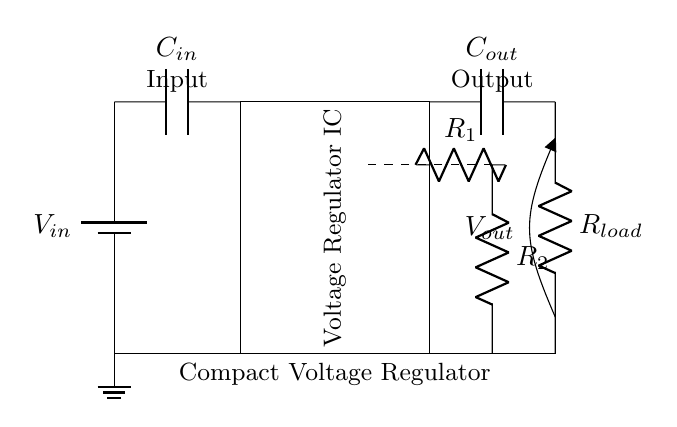What is the input voltage source labeled as? The input voltage source is labeled as V in, which indicates the voltage entering the circuit from an external battery.
Answer: V in What type of component is used to filter the input voltage? The component used to filter the input voltage is a capacitor, labeled C in, positioned immediately after the input voltage source.
Answer: C in How many resistors are present in the feedback section? There are two resistors present in the feedback section, labeled R 1 and R 2, which are critical for setting the output voltage of the regulator.
Answer: 2 What component provides the output voltage? The output voltage is provided by the load resistor, labeled R load, which connects the output capacitor to ground, allowing the load to draw current.
Answer: R load What is the label of the main voltage regulator component? The main voltage regulator component is labeled as Voltage Regulator IC, indicating it is an integrated circuit that regulates the output voltage.
Answer: Voltage Regulator IC Which capacitors are used in the circuit? The circuit uses two capacitors: one labeled C in for input filtering and another labeled C out for output smoothing.
Answer: C in and C out What is the function of the dashed line connection in the circuit? The dashed line connection represents the feedback path that links the output voltage back to the regulation mechanism, ensuring stable output.
Answer: Feedback connection 